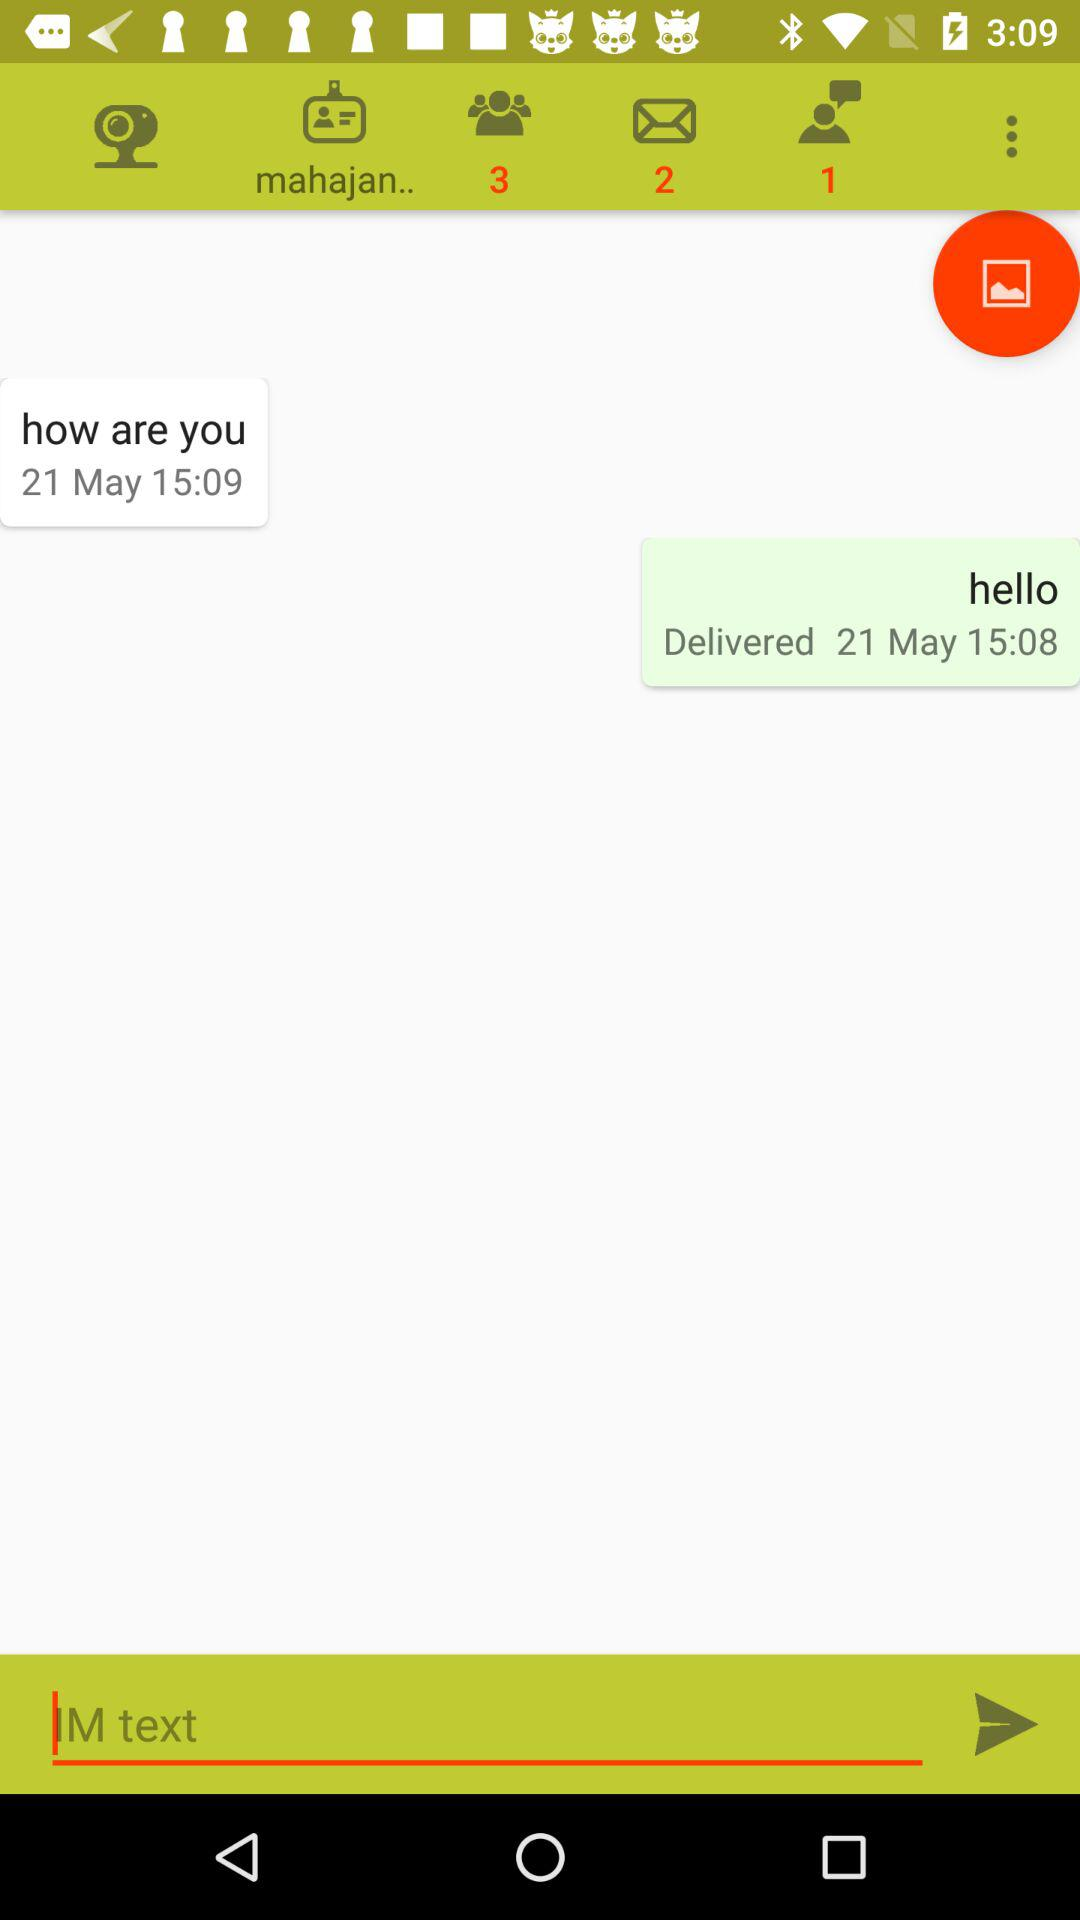How many unread notifications are there in groups? There are 3 unread notifications in groups. 